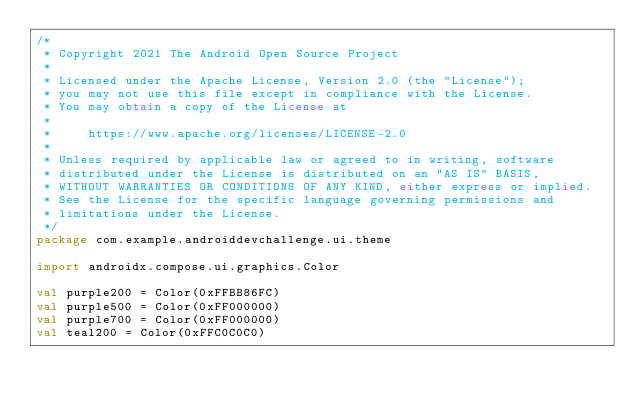<code> <loc_0><loc_0><loc_500><loc_500><_Kotlin_>/*
 * Copyright 2021 The Android Open Source Project
 *
 * Licensed under the Apache License, Version 2.0 (the "License");
 * you may not use this file except in compliance with the License.
 * You may obtain a copy of the License at
 *
 *     https://www.apache.org/licenses/LICENSE-2.0
 *
 * Unless required by applicable law or agreed to in writing, software
 * distributed under the License is distributed on an "AS IS" BASIS,
 * WITHOUT WARRANTIES OR CONDITIONS OF ANY KIND, either express or implied.
 * See the License for the specific language governing permissions and
 * limitations under the License.
 */
package com.example.androiddevchallenge.ui.theme

import androidx.compose.ui.graphics.Color

val purple200 = Color(0xFFBB86FC)
val purple500 = Color(0xFF000000)
val purple700 = Color(0xFF000000)
val teal200 = Color(0xFFC0C0C0)
</code> 